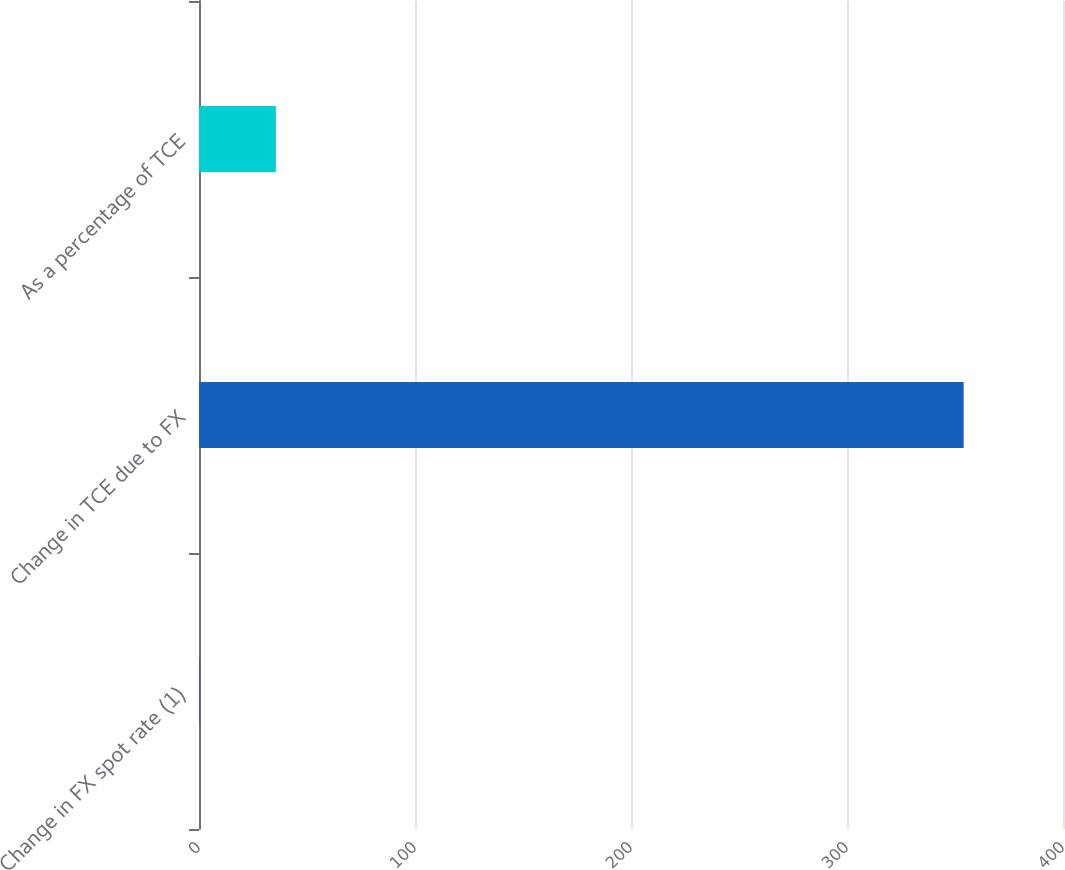Convert chart. <chart><loc_0><loc_0><loc_500><loc_500><bar_chart><fcel>Change in FX spot rate (1)<fcel>Change in TCE due to FX<fcel>As a percentage of TCE<nl><fcel>0.2<fcel>354<fcel>35.58<nl></chart> 